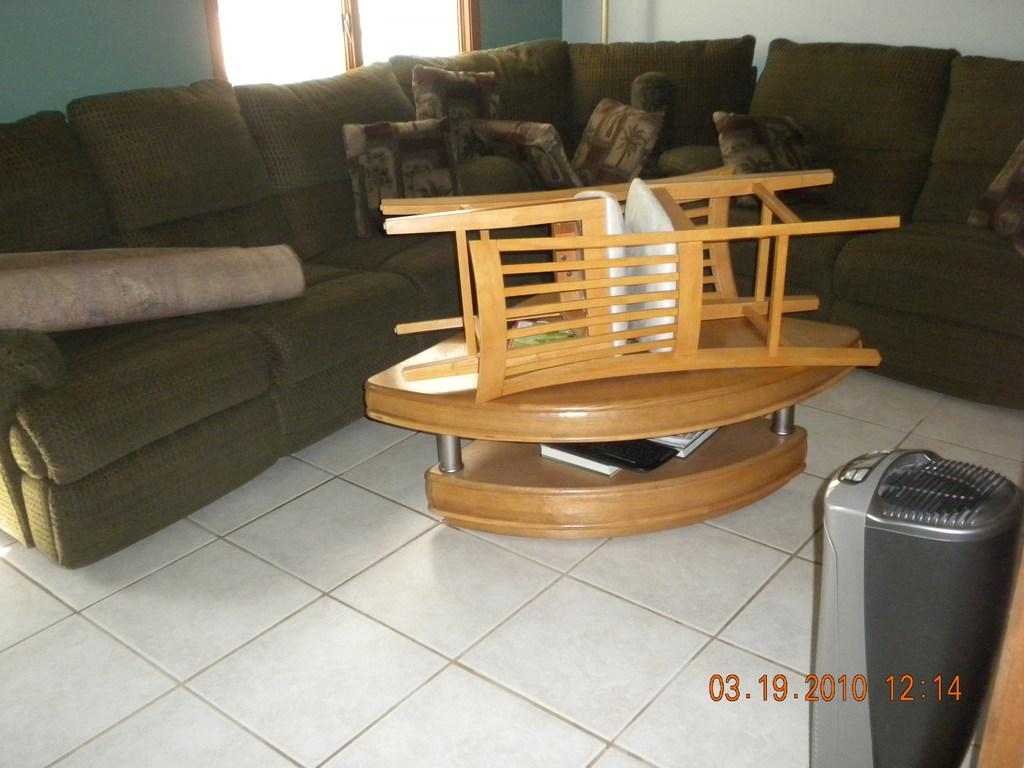What type of furniture is present in the image? There is a sofa in the image. What is placed on the sofa? There are pillows on the sofa. What can be seen beneath the furniture? There is a floor visible in the image. What other piece of furniture is present in the image? There is a table in the image. How many chairs are visible in the image? There are chairs in the image. What can be seen in the background of the image? There is a wall and a window in the background of the image. What type of jam is being spread on the balls in the image? There are no balls or jam present in the image. Is there a cellar visible in the image? There is no cellar visible in the image. 